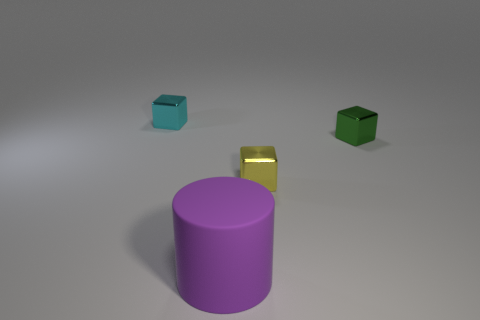Is there anything else that has the same material as the big object?
Make the answer very short. No. Are there any blocks made of the same material as the yellow object?
Offer a very short reply. Yes. Are the large cylinder and the tiny yellow thing made of the same material?
Provide a succinct answer. No. How many balls are either cyan shiny things or metal things?
Ensure brevity in your answer.  0. Are there fewer yellow cubes than small gray rubber cylinders?
Offer a very short reply. No. There is a tiny metal thing that is in front of the tiny green thing; does it have the same shape as the small metal object that is behind the small green metallic block?
Offer a very short reply. Yes. What number of things are green cubes or cubes?
Keep it short and to the point. 3. There is a metallic block that is to the left of the cylinder; how many small green metal blocks are to the left of it?
Offer a very short reply. 0. How many small shiny things are on the left side of the tiny green metallic block and in front of the tiny cyan metallic cube?
Give a very brief answer. 1. What number of objects are cyan cubes to the left of the large cylinder or metallic blocks that are on the left side of the large cylinder?
Ensure brevity in your answer.  1. 